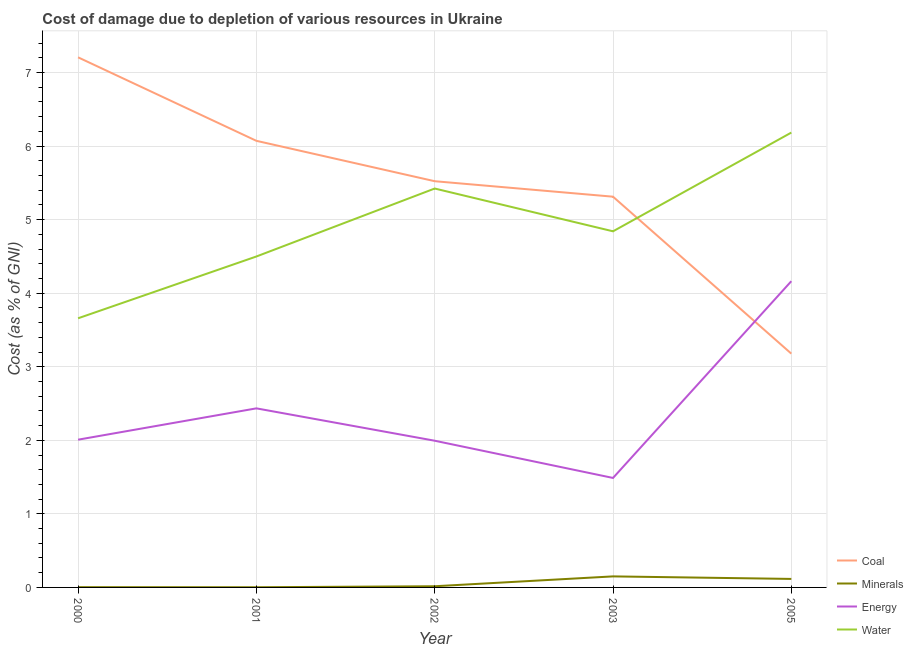How many different coloured lines are there?
Ensure brevity in your answer.  4. Is the number of lines equal to the number of legend labels?
Make the answer very short. Yes. What is the cost of damage due to depletion of coal in 2003?
Ensure brevity in your answer.  5.31. Across all years, what is the maximum cost of damage due to depletion of energy?
Provide a succinct answer. 4.16. Across all years, what is the minimum cost of damage due to depletion of energy?
Your answer should be very brief. 1.49. In which year was the cost of damage due to depletion of minerals maximum?
Make the answer very short. 2003. In which year was the cost of damage due to depletion of water minimum?
Your response must be concise. 2000. What is the total cost of damage due to depletion of energy in the graph?
Your answer should be very brief. 12.09. What is the difference between the cost of damage due to depletion of coal in 2000 and that in 2001?
Provide a short and direct response. 1.14. What is the difference between the cost of damage due to depletion of coal in 2001 and the cost of damage due to depletion of minerals in 2003?
Ensure brevity in your answer.  5.92. What is the average cost of damage due to depletion of coal per year?
Give a very brief answer. 5.46. In the year 2001, what is the difference between the cost of damage due to depletion of water and cost of damage due to depletion of minerals?
Ensure brevity in your answer.  4.5. What is the ratio of the cost of damage due to depletion of coal in 2000 to that in 2005?
Your answer should be compact. 2.27. What is the difference between the highest and the second highest cost of damage due to depletion of energy?
Give a very brief answer. 1.73. What is the difference between the highest and the lowest cost of damage due to depletion of minerals?
Your response must be concise. 0.15. In how many years, is the cost of damage due to depletion of water greater than the average cost of damage due to depletion of water taken over all years?
Offer a terse response. 2. Is it the case that in every year, the sum of the cost of damage due to depletion of coal and cost of damage due to depletion of minerals is greater than the cost of damage due to depletion of energy?
Your response must be concise. No. Does the cost of damage due to depletion of coal monotonically increase over the years?
Ensure brevity in your answer.  No. What is the difference between two consecutive major ticks on the Y-axis?
Ensure brevity in your answer.  1. Are the values on the major ticks of Y-axis written in scientific E-notation?
Your answer should be compact. No. Where does the legend appear in the graph?
Provide a succinct answer. Bottom right. How many legend labels are there?
Provide a succinct answer. 4. How are the legend labels stacked?
Offer a very short reply. Vertical. What is the title of the graph?
Offer a very short reply. Cost of damage due to depletion of various resources in Ukraine . Does "UNHCR" appear as one of the legend labels in the graph?
Give a very brief answer. No. What is the label or title of the Y-axis?
Give a very brief answer. Cost (as % of GNI). What is the Cost (as % of GNI) in Coal in 2000?
Provide a short and direct response. 7.21. What is the Cost (as % of GNI) in Minerals in 2000?
Offer a terse response. 0. What is the Cost (as % of GNI) in Energy in 2000?
Provide a succinct answer. 2.01. What is the Cost (as % of GNI) of Water in 2000?
Provide a short and direct response. 3.66. What is the Cost (as % of GNI) of Coal in 2001?
Keep it short and to the point. 6.07. What is the Cost (as % of GNI) in Minerals in 2001?
Offer a very short reply. 0. What is the Cost (as % of GNI) of Energy in 2001?
Your answer should be very brief. 2.43. What is the Cost (as % of GNI) in Water in 2001?
Give a very brief answer. 4.5. What is the Cost (as % of GNI) in Coal in 2002?
Offer a terse response. 5.52. What is the Cost (as % of GNI) in Minerals in 2002?
Offer a very short reply. 0.02. What is the Cost (as % of GNI) in Energy in 2002?
Provide a short and direct response. 1.99. What is the Cost (as % of GNI) in Water in 2002?
Keep it short and to the point. 5.42. What is the Cost (as % of GNI) of Coal in 2003?
Ensure brevity in your answer.  5.31. What is the Cost (as % of GNI) of Minerals in 2003?
Your answer should be compact. 0.15. What is the Cost (as % of GNI) of Energy in 2003?
Ensure brevity in your answer.  1.49. What is the Cost (as % of GNI) in Water in 2003?
Offer a very short reply. 4.84. What is the Cost (as % of GNI) of Coal in 2005?
Offer a terse response. 3.18. What is the Cost (as % of GNI) in Minerals in 2005?
Offer a very short reply. 0.12. What is the Cost (as % of GNI) of Energy in 2005?
Make the answer very short. 4.16. What is the Cost (as % of GNI) in Water in 2005?
Give a very brief answer. 6.18. Across all years, what is the maximum Cost (as % of GNI) of Coal?
Offer a terse response. 7.21. Across all years, what is the maximum Cost (as % of GNI) in Minerals?
Your answer should be compact. 0.15. Across all years, what is the maximum Cost (as % of GNI) of Energy?
Your response must be concise. 4.16. Across all years, what is the maximum Cost (as % of GNI) in Water?
Your answer should be very brief. 6.18. Across all years, what is the minimum Cost (as % of GNI) of Coal?
Ensure brevity in your answer.  3.18. Across all years, what is the minimum Cost (as % of GNI) of Minerals?
Your response must be concise. 0. Across all years, what is the minimum Cost (as % of GNI) in Energy?
Your answer should be very brief. 1.49. Across all years, what is the minimum Cost (as % of GNI) of Water?
Keep it short and to the point. 3.66. What is the total Cost (as % of GNI) in Coal in the graph?
Your response must be concise. 27.29. What is the total Cost (as % of GNI) in Minerals in the graph?
Offer a terse response. 0.29. What is the total Cost (as % of GNI) in Energy in the graph?
Offer a very short reply. 12.09. What is the total Cost (as % of GNI) of Water in the graph?
Offer a terse response. 24.6. What is the difference between the Cost (as % of GNI) in Coal in 2000 and that in 2001?
Your response must be concise. 1.14. What is the difference between the Cost (as % of GNI) of Minerals in 2000 and that in 2001?
Give a very brief answer. 0. What is the difference between the Cost (as % of GNI) of Energy in 2000 and that in 2001?
Give a very brief answer. -0.43. What is the difference between the Cost (as % of GNI) in Water in 2000 and that in 2001?
Your answer should be compact. -0.84. What is the difference between the Cost (as % of GNI) of Coal in 2000 and that in 2002?
Offer a terse response. 1.68. What is the difference between the Cost (as % of GNI) of Minerals in 2000 and that in 2002?
Ensure brevity in your answer.  -0.01. What is the difference between the Cost (as % of GNI) in Energy in 2000 and that in 2002?
Your answer should be compact. 0.01. What is the difference between the Cost (as % of GNI) of Water in 2000 and that in 2002?
Ensure brevity in your answer.  -1.76. What is the difference between the Cost (as % of GNI) of Coal in 2000 and that in 2003?
Offer a very short reply. 1.89. What is the difference between the Cost (as % of GNI) in Minerals in 2000 and that in 2003?
Ensure brevity in your answer.  -0.15. What is the difference between the Cost (as % of GNI) in Energy in 2000 and that in 2003?
Provide a short and direct response. 0.52. What is the difference between the Cost (as % of GNI) of Water in 2000 and that in 2003?
Provide a succinct answer. -1.18. What is the difference between the Cost (as % of GNI) of Coal in 2000 and that in 2005?
Provide a succinct answer. 4.03. What is the difference between the Cost (as % of GNI) of Minerals in 2000 and that in 2005?
Provide a short and direct response. -0.11. What is the difference between the Cost (as % of GNI) in Energy in 2000 and that in 2005?
Keep it short and to the point. -2.15. What is the difference between the Cost (as % of GNI) of Water in 2000 and that in 2005?
Provide a short and direct response. -2.52. What is the difference between the Cost (as % of GNI) in Coal in 2001 and that in 2002?
Your answer should be very brief. 0.55. What is the difference between the Cost (as % of GNI) of Minerals in 2001 and that in 2002?
Give a very brief answer. -0.01. What is the difference between the Cost (as % of GNI) of Energy in 2001 and that in 2002?
Give a very brief answer. 0.44. What is the difference between the Cost (as % of GNI) in Water in 2001 and that in 2002?
Your response must be concise. -0.92. What is the difference between the Cost (as % of GNI) of Coal in 2001 and that in 2003?
Provide a short and direct response. 0.76. What is the difference between the Cost (as % of GNI) in Minerals in 2001 and that in 2003?
Give a very brief answer. -0.15. What is the difference between the Cost (as % of GNI) in Energy in 2001 and that in 2003?
Give a very brief answer. 0.95. What is the difference between the Cost (as % of GNI) of Water in 2001 and that in 2003?
Make the answer very short. -0.34. What is the difference between the Cost (as % of GNI) in Coal in 2001 and that in 2005?
Provide a short and direct response. 2.89. What is the difference between the Cost (as % of GNI) in Minerals in 2001 and that in 2005?
Ensure brevity in your answer.  -0.11. What is the difference between the Cost (as % of GNI) of Energy in 2001 and that in 2005?
Keep it short and to the point. -1.73. What is the difference between the Cost (as % of GNI) in Water in 2001 and that in 2005?
Give a very brief answer. -1.68. What is the difference between the Cost (as % of GNI) of Coal in 2002 and that in 2003?
Your answer should be compact. 0.21. What is the difference between the Cost (as % of GNI) of Minerals in 2002 and that in 2003?
Your answer should be very brief. -0.13. What is the difference between the Cost (as % of GNI) in Energy in 2002 and that in 2003?
Your response must be concise. 0.51. What is the difference between the Cost (as % of GNI) in Water in 2002 and that in 2003?
Your answer should be very brief. 0.58. What is the difference between the Cost (as % of GNI) of Coal in 2002 and that in 2005?
Provide a succinct answer. 2.34. What is the difference between the Cost (as % of GNI) in Minerals in 2002 and that in 2005?
Your answer should be very brief. -0.1. What is the difference between the Cost (as % of GNI) of Energy in 2002 and that in 2005?
Your answer should be compact. -2.17. What is the difference between the Cost (as % of GNI) of Water in 2002 and that in 2005?
Your answer should be compact. -0.76. What is the difference between the Cost (as % of GNI) in Coal in 2003 and that in 2005?
Keep it short and to the point. 2.13. What is the difference between the Cost (as % of GNI) in Minerals in 2003 and that in 2005?
Keep it short and to the point. 0.03. What is the difference between the Cost (as % of GNI) in Energy in 2003 and that in 2005?
Make the answer very short. -2.67. What is the difference between the Cost (as % of GNI) in Water in 2003 and that in 2005?
Offer a very short reply. -1.34. What is the difference between the Cost (as % of GNI) in Coal in 2000 and the Cost (as % of GNI) in Minerals in 2001?
Give a very brief answer. 7.2. What is the difference between the Cost (as % of GNI) of Coal in 2000 and the Cost (as % of GNI) of Energy in 2001?
Offer a terse response. 4.77. What is the difference between the Cost (as % of GNI) of Coal in 2000 and the Cost (as % of GNI) of Water in 2001?
Offer a terse response. 2.71. What is the difference between the Cost (as % of GNI) in Minerals in 2000 and the Cost (as % of GNI) in Energy in 2001?
Make the answer very short. -2.43. What is the difference between the Cost (as % of GNI) of Minerals in 2000 and the Cost (as % of GNI) of Water in 2001?
Provide a short and direct response. -4.49. What is the difference between the Cost (as % of GNI) of Energy in 2000 and the Cost (as % of GNI) of Water in 2001?
Provide a short and direct response. -2.49. What is the difference between the Cost (as % of GNI) in Coal in 2000 and the Cost (as % of GNI) in Minerals in 2002?
Make the answer very short. 7.19. What is the difference between the Cost (as % of GNI) in Coal in 2000 and the Cost (as % of GNI) in Energy in 2002?
Ensure brevity in your answer.  5.21. What is the difference between the Cost (as % of GNI) in Coal in 2000 and the Cost (as % of GNI) in Water in 2002?
Make the answer very short. 1.78. What is the difference between the Cost (as % of GNI) of Minerals in 2000 and the Cost (as % of GNI) of Energy in 2002?
Offer a very short reply. -1.99. What is the difference between the Cost (as % of GNI) of Minerals in 2000 and the Cost (as % of GNI) of Water in 2002?
Make the answer very short. -5.42. What is the difference between the Cost (as % of GNI) in Energy in 2000 and the Cost (as % of GNI) in Water in 2002?
Provide a succinct answer. -3.41. What is the difference between the Cost (as % of GNI) of Coal in 2000 and the Cost (as % of GNI) of Minerals in 2003?
Your answer should be compact. 7.06. What is the difference between the Cost (as % of GNI) of Coal in 2000 and the Cost (as % of GNI) of Energy in 2003?
Provide a short and direct response. 5.72. What is the difference between the Cost (as % of GNI) of Coal in 2000 and the Cost (as % of GNI) of Water in 2003?
Make the answer very short. 2.37. What is the difference between the Cost (as % of GNI) of Minerals in 2000 and the Cost (as % of GNI) of Energy in 2003?
Your answer should be very brief. -1.48. What is the difference between the Cost (as % of GNI) of Minerals in 2000 and the Cost (as % of GNI) of Water in 2003?
Your answer should be compact. -4.84. What is the difference between the Cost (as % of GNI) in Energy in 2000 and the Cost (as % of GNI) in Water in 2003?
Offer a very short reply. -2.83. What is the difference between the Cost (as % of GNI) of Coal in 2000 and the Cost (as % of GNI) of Minerals in 2005?
Provide a succinct answer. 7.09. What is the difference between the Cost (as % of GNI) in Coal in 2000 and the Cost (as % of GNI) in Energy in 2005?
Your response must be concise. 3.04. What is the difference between the Cost (as % of GNI) in Minerals in 2000 and the Cost (as % of GNI) in Energy in 2005?
Provide a succinct answer. -4.16. What is the difference between the Cost (as % of GNI) in Minerals in 2000 and the Cost (as % of GNI) in Water in 2005?
Keep it short and to the point. -6.18. What is the difference between the Cost (as % of GNI) in Energy in 2000 and the Cost (as % of GNI) in Water in 2005?
Keep it short and to the point. -4.17. What is the difference between the Cost (as % of GNI) in Coal in 2001 and the Cost (as % of GNI) in Minerals in 2002?
Ensure brevity in your answer.  6.05. What is the difference between the Cost (as % of GNI) in Coal in 2001 and the Cost (as % of GNI) in Energy in 2002?
Keep it short and to the point. 4.08. What is the difference between the Cost (as % of GNI) in Coal in 2001 and the Cost (as % of GNI) in Water in 2002?
Your answer should be very brief. 0.65. What is the difference between the Cost (as % of GNI) in Minerals in 2001 and the Cost (as % of GNI) in Energy in 2002?
Your answer should be compact. -1.99. What is the difference between the Cost (as % of GNI) of Minerals in 2001 and the Cost (as % of GNI) of Water in 2002?
Your answer should be compact. -5.42. What is the difference between the Cost (as % of GNI) in Energy in 2001 and the Cost (as % of GNI) in Water in 2002?
Keep it short and to the point. -2.99. What is the difference between the Cost (as % of GNI) of Coal in 2001 and the Cost (as % of GNI) of Minerals in 2003?
Give a very brief answer. 5.92. What is the difference between the Cost (as % of GNI) in Coal in 2001 and the Cost (as % of GNI) in Energy in 2003?
Keep it short and to the point. 4.58. What is the difference between the Cost (as % of GNI) in Coal in 2001 and the Cost (as % of GNI) in Water in 2003?
Ensure brevity in your answer.  1.23. What is the difference between the Cost (as % of GNI) in Minerals in 2001 and the Cost (as % of GNI) in Energy in 2003?
Make the answer very short. -1.49. What is the difference between the Cost (as % of GNI) in Minerals in 2001 and the Cost (as % of GNI) in Water in 2003?
Keep it short and to the point. -4.84. What is the difference between the Cost (as % of GNI) of Energy in 2001 and the Cost (as % of GNI) of Water in 2003?
Ensure brevity in your answer.  -2.41. What is the difference between the Cost (as % of GNI) of Coal in 2001 and the Cost (as % of GNI) of Minerals in 2005?
Ensure brevity in your answer.  5.96. What is the difference between the Cost (as % of GNI) in Coal in 2001 and the Cost (as % of GNI) in Energy in 2005?
Your answer should be very brief. 1.91. What is the difference between the Cost (as % of GNI) of Coal in 2001 and the Cost (as % of GNI) of Water in 2005?
Offer a terse response. -0.11. What is the difference between the Cost (as % of GNI) of Minerals in 2001 and the Cost (as % of GNI) of Energy in 2005?
Keep it short and to the point. -4.16. What is the difference between the Cost (as % of GNI) of Minerals in 2001 and the Cost (as % of GNI) of Water in 2005?
Your answer should be very brief. -6.18. What is the difference between the Cost (as % of GNI) in Energy in 2001 and the Cost (as % of GNI) in Water in 2005?
Your answer should be very brief. -3.75. What is the difference between the Cost (as % of GNI) of Coal in 2002 and the Cost (as % of GNI) of Minerals in 2003?
Your answer should be compact. 5.37. What is the difference between the Cost (as % of GNI) of Coal in 2002 and the Cost (as % of GNI) of Energy in 2003?
Provide a succinct answer. 4.03. What is the difference between the Cost (as % of GNI) of Coal in 2002 and the Cost (as % of GNI) of Water in 2003?
Provide a succinct answer. 0.68. What is the difference between the Cost (as % of GNI) in Minerals in 2002 and the Cost (as % of GNI) in Energy in 2003?
Provide a succinct answer. -1.47. What is the difference between the Cost (as % of GNI) of Minerals in 2002 and the Cost (as % of GNI) of Water in 2003?
Provide a short and direct response. -4.82. What is the difference between the Cost (as % of GNI) in Energy in 2002 and the Cost (as % of GNI) in Water in 2003?
Make the answer very short. -2.85. What is the difference between the Cost (as % of GNI) in Coal in 2002 and the Cost (as % of GNI) in Minerals in 2005?
Keep it short and to the point. 5.41. What is the difference between the Cost (as % of GNI) of Coal in 2002 and the Cost (as % of GNI) of Energy in 2005?
Offer a very short reply. 1.36. What is the difference between the Cost (as % of GNI) of Coal in 2002 and the Cost (as % of GNI) of Water in 2005?
Keep it short and to the point. -0.66. What is the difference between the Cost (as % of GNI) in Minerals in 2002 and the Cost (as % of GNI) in Energy in 2005?
Give a very brief answer. -4.15. What is the difference between the Cost (as % of GNI) of Minerals in 2002 and the Cost (as % of GNI) of Water in 2005?
Your answer should be very brief. -6.17. What is the difference between the Cost (as % of GNI) of Energy in 2002 and the Cost (as % of GNI) of Water in 2005?
Provide a succinct answer. -4.19. What is the difference between the Cost (as % of GNI) of Coal in 2003 and the Cost (as % of GNI) of Minerals in 2005?
Your response must be concise. 5.2. What is the difference between the Cost (as % of GNI) in Coal in 2003 and the Cost (as % of GNI) in Energy in 2005?
Your response must be concise. 1.15. What is the difference between the Cost (as % of GNI) of Coal in 2003 and the Cost (as % of GNI) of Water in 2005?
Your response must be concise. -0.87. What is the difference between the Cost (as % of GNI) in Minerals in 2003 and the Cost (as % of GNI) in Energy in 2005?
Offer a terse response. -4.01. What is the difference between the Cost (as % of GNI) of Minerals in 2003 and the Cost (as % of GNI) of Water in 2005?
Offer a very short reply. -6.03. What is the difference between the Cost (as % of GNI) of Energy in 2003 and the Cost (as % of GNI) of Water in 2005?
Offer a terse response. -4.69. What is the average Cost (as % of GNI) of Coal per year?
Give a very brief answer. 5.46. What is the average Cost (as % of GNI) of Minerals per year?
Your response must be concise. 0.06. What is the average Cost (as % of GNI) of Energy per year?
Your answer should be compact. 2.42. What is the average Cost (as % of GNI) in Water per year?
Provide a short and direct response. 4.92. In the year 2000, what is the difference between the Cost (as % of GNI) in Coal and Cost (as % of GNI) in Minerals?
Your answer should be very brief. 7.2. In the year 2000, what is the difference between the Cost (as % of GNI) of Coal and Cost (as % of GNI) of Energy?
Give a very brief answer. 5.2. In the year 2000, what is the difference between the Cost (as % of GNI) in Coal and Cost (as % of GNI) in Water?
Your response must be concise. 3.55. In the year 2000, what is the difference between the Cost (as % of GNI) of Minerals and Cost (as % of GNI) of Energy?
Make the answer very short. -2. In the year 2000, what is the difference between the Cost (as % of GNI) of Minerals and Cost (as % of GNI) of Water?
Keep it short and to the point. -3.65. In the year 2000, what is the difference between the Cost (as % of GNI) of Energy and Cost (as % of GNI) of Water?
Offer a terse response. -1.65. In the year 2001, what is the difference between the Cost (as % of GNI) in Coal and Cost (as % of GNI) in Minerals?
Offer a terse response. 6.07. In the year 2001, what is the difference between the Cost (as % of GNI) in Coal and Cost (as % of GNI) in Energy?
Provide a succinct answer. 3.64. In the year 2001, what is the difference between the Cost (as % of GNI) of Coal and Cost (as % of GNI) of Water?
Your answer should be compact. 1.57. In the year 2001, what is the difference between the Cost (as % of GNI) of Minerals and Cost (as % of GNI) of Energy?
Give a very brief answer. -2.43. In the year 2001, what is the difference between the Cost (as % of GNI) in Minerals and Cost (as % of GNI) in Water?
Ensure brevity in your answer.  -4.5. In the year 2001, what is the difference between the Cost (as % of GNI) in Energy and Cost (as % of GNI) in Water?
Keep it short and to the point. -2.06. In the year 2002, what is the difference between the Cost (as % of GNI) of Coal and Cost (as % of GNI) of Minerals?
Your response must be concise. 5.51. In the year 2002, what is the difference between the Cost (as % of GNI) of Coal and Cost (as % of GNI) of Energy?
Provide a succinct answer. 3.53. In the year 2002, what is the difference between the Cost (as % of GNI) in Coal and Cost (as % of GNI) in Water?
Your response must be concise. 0.1. In the year 2002, what is the difference between the Cost (as % of GNI) in Minerals and Cost (as % of GNI) in Energy?
Provide a short and direct response. -1.98. In the year 2002, what is the difference between the Cost (as % of GNI) in Minerals and Cost (as % of GNI) in Water?
Give a very brief answer. -5.41. In the year 2002, what is the difference between the Cost (as % of GNI) in Energy and Cost (as % of GNI) in Water?
Give a very brief answer. -3.43. In the year 2003, what is the difference between the Cost (as % of GNI) in Coal and Cost (as % of GNI) in Minerals?
Your answer should be very brief. 5.16. In the year 2003, what is the difference between the Cost (as % of GNI) of Coal and Cost (as % of GNI) of Energy?
Offer a terse response. 3.82. In the year 2003, what is the difference between the Cost (as % of GNI) of Coal and Cost (as % of GNI) of Water?
Give a very brief answer. 0.47. In the year 2003, what is the difference between the Cost (as % of GNI) of Minerals and Cost (as % of GNI) of Energy?
Your answer should be very brief. -1.34. In the year 2003, what is the difference between the Cost (as % of GNI) in Minerals and Cost (as % of GNI) in Water?
Your answer should be very brief. -4.69. In the year 2003, what is the difference between the Cost (as % of GNI) of Energy and Cost (as % of GNI) of Water?
Keep it short and to the point. -3.35. In the year 2005, what is the difference between the Cost (as % of GNI) in Coal and Cost (as % of GNI) in Minerals?
Give a very brief answer. 3.06. In the year 2005, what is the difference between the Cost (as % of GNI) of Coal and Cost (as % of GNI) of Energy?
Provide a short and direct response. -0.98. In the year 2005, what is the difference between the Cost (as % of GNI) of Coal and Cost (as % of GNI) of Water?
Give a very brief answer. -3. In the year 2005, what is the difference between the Cost (as % of GNI) in Minerals and Cost (as % of GNI) in Energy?
Offer a terse response. -4.05. In the year 2005, what is the difference between the Cost (as % of GNI) of Minerals and Cost (as % of GNI) of Water?
Your answer should be compact. -6.07. In the year 2005, what is the difference between the Cost (as % of GNI) of Energy and Cost (as % of GNI) of Water?
Your answer should be compact. -2.02. What is the ratio of the Cost (as % of GNI) of Coal in 2000 to that in 2001?
Provide a short and direct response. 1.19. What is the ratio of the Cost (as % of GNI) in Minerals in 2000 to that in 2001?
Keep it short and to the point. 1.46. What is the ratio of the Cost (as % of GNI) in Energy in 2000 to that in 2001?
Your response must be concise. 0.82. What is the ratio of the Cost (as % of GNI) of Water in 2000 to that in 2001?
Provide a short and direct response. 0.81. What is the ratio of the Cost (as % of GNI) of Coal in 2000 to that in 2002?
Offer a very short reply. 1.3. What is the ratio of the Cost (as % of GNI) of Minerals in 2000 to that in 2002?
Your answer should be compact. 0.23. What is the ratio of the Cost (as % of GNI) of Energy in 2000 to that in 2002?
Provide a short and direct response. 1.01. What is the ratio of the Cost (as % of GNI) in Water in 2000 to that in 2002?
Ensure brevity in your answer.  0.67. What is the ratio of the Cost (as % of GNI) in Coal in 2000 to that in 2003?
Your response must be concise. 1.36. What is the ratio of the Cost (as % of GNI) of Minerals in 2000 to that in 2003?
Give a very brief answer. 0.02. What is the ratio of the Cost (as % of GNI) in Energy in 2000 to that in 2003?
Make the answer very short. 1.35. What is the ratio of the Cost (as % of GNI) in Water in 2000 to that in 2003?
Make the answer very short. 0.76. What is the ratio of the Cost (as % of GNI) in Coal in 2000 to that in 2005?
Give a very brief answer. 2.27. What is the ratio of the Cost (as % of GNI) in Minerals in 2000 to that in 2005?
Give a very brief answer. 0.03. What is the ratio of the Cost (as % of GNI) in Energy in 2000 to that in 2005?
Your answer should be very brief. 0.48. What is the ratio of the Cost (as % of GNI) in Water in 2000 to that in 2005?
Provide a short and direct response. 0.59. What is the ratio of the Cost (as % of GNI) in Coal in 2001 to that in 2002?
Ensure brevity in your answer.  1.1. What is the ratio of the Cost (as % of GNI) in Minerals in 2001 to that in 2002?
Provide a short and direct response. 0.16. What is the ratio of the Cost (as % of GNI) of Energy in 2001 to that in 2002?
Offer a terse response. 1.22. What is the ratio of the Cost (as % of GNI) in Water in 2001 to that in 2002?
Offer a terse response. 0.83. What is the ratio of the Cost (as % of GNI) in Coal in 2001 to that in 2003?
Ensure brevity in your answer.  1.14. What is the ratio of the Cost (as % of GNI) of Minerals in 2001 to that in 2003?
Your answer should be compact. 0.02. What is the ratio of the Cost (as % of GNI) of Energy in 2001 to that in 2003?
Offer a terse response. 1.64. What is the ratio of the Cost (as % of GNI) of Water in 2001 to that in 2003?
Your answer should be compact. 0.93. What is the ratio of the Cost (as % of GNI) of Coal in 2001 to that in 2005?
Give a very brief answer. 1.91. What is the ratio of the Cost (as % of GNI) of Minerals in 2001 to that in 2005?
Keep it short and to the point. 0.02. What is the ratio of the Cost (as % of GNI) in Energy in 2001 to that in 2005?
Your response must be concise. 0.58. What is the ratio of the Cost (as % of GNI) of Water in 2001 to that in 2005?
Your answer should be compact. 0.73. What is the ratio of the Cost (as % of GNI) of Coal in 2002 to that in 2003?
Offer a very short reply. 1.04. What is the ratio of the Cost (as % of GNI) in Minerals in 2002 to that in 2003?
Your answer should be very brief. 0.11. What is the ratio of the Cost (as % of GNI) in Energy in 2002 to that in 2003?
Provide a short and direct response. 1.34. What is the ratio of the Cost (as % of GNI) of Water in 2002 to that in 2003?
Provide a succinct answer. 1.12. What is the ratio of the Cost (as % of GNI) in Coal in 2002 to that in 2005?
Your answer should be compact. 1.74. What is the ratio of the Cost (as % of GNI) in Minerals in 2002 to that in 2005?
Offer a terse response. 0.14. What is the ratio of the Cost (as % of GNI) of Energy in 2002 to that in 2005?
Give a very brief answer. 0.48. What is the ratio of the Cost (as % of GNI) in Water in 2002 to that in 2005?
Provide a short and direct response. 0.88. What is the ratio of the Cost (as % of GNI) in Coal in 2003 to that in 2005?
Offer a very short reply. 1.67. What is the ratio of the Cost (as % of GNI) of Minerals in 2003 to that in 2005?
Your response must be concise. 1.3. What is the ratio of the Cost (as % of GNI) of Energy in 2003 to that in 2005?
Ensure brevity in your answer.  0.36. What is the ratio of the Cost (as % of GNI) in Water in 2003 to that in 2005?
Offer a terse response. 0.78. What is the difference between the highest and the second highest Cost (as % of GNI) in Coal?
Provide a short and direct response. 1.14. What is the difference between the highest and the second highest Cost (as % of GNI) of Minerals?
Ensure brevity in your answer.  0.03. What is the difference between the highest and the second highest Cost (as % of GNI) of Energy?
Your answer should be very brief. 1.73. What is the difference between the highest and the second highest Cost (as % of GNI) in Water?
Your answer should be compact. 0.76. What is the difference between the highest and the lowest Cost (as % of GNI) in Coal?
Keep it short and to the point. 4.03. What is the difference between the highest and the lowest Cost (as % of GNI) of Minerals?
Provide a short and direct response. 0.15. What is the difference between the highest and the lowest Cost (as % of GNI) of Energy?
Your answer should be compact. 2.67. What is the difference between the highest and the lowest Cost (as % of GNI) of Water?
Offer a terse response. 2.52. 